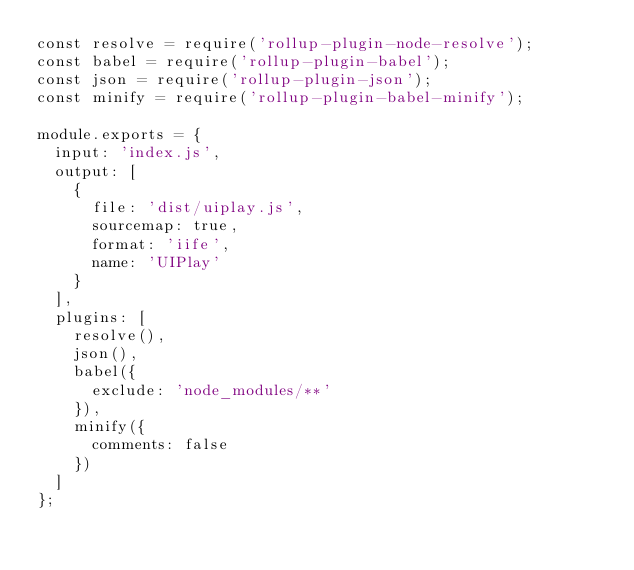<code> <loc_0><loc_0><loc_500><loc_500><_JavaScript_>const resolve = require('rollup-plugin-node-resolve');
const babel = require('rollup-plugin-babel');
const json = require('rollup-plugin-json');
const minify = require('rollup-plugin-babel-minify'); 

module.exports = {
  input: 'index.js',
  output: [
    {
      file: 'dist/uiplay.js',
      sourcemap: true,
      format: 'iife',
      name: 'UIPlay'
    }
  ],
  plugins: [
    resolve(),
    json(),
    babel({
      exclude: 'node_modules/**'
    }),
    minify({
      comments: false
    })
  ]
};
</code> 